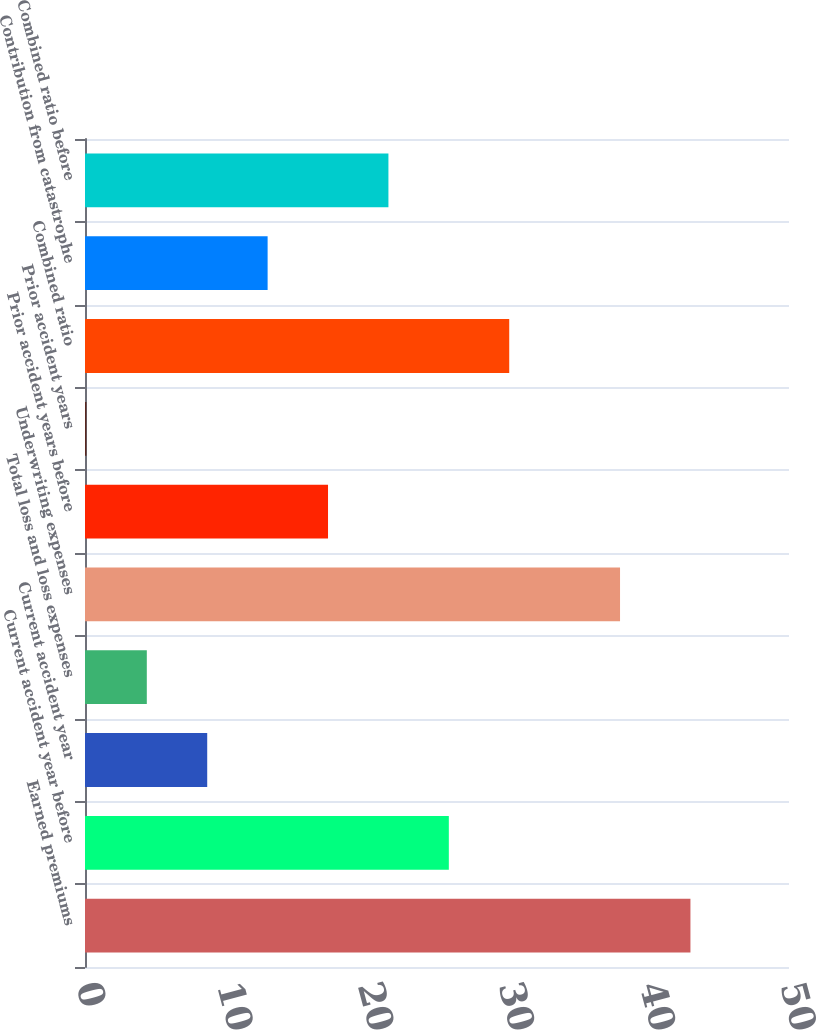Convert chart to OTSL. <chart><loc_0><loc_0><loc_500><loc_500><bar_chart><fcel>Earned premiums<fcel>Current accident year before<fcel>Current accident year<fcel>Total loss and loss expenses<fcel>Underwriting expenses<fcel>Prior accident years before<fcel>Prior accident years<fcel>Combined ratio<fcel>Contribution from catastrophe<fcel>Combined ratio before<nl><fcel>43<fcel>25.84<fcel>8.68<fcel>4.39<fcel>38<fcel>17.26<fcel>0.1<fcel>30.13<fcel>12.97<fcel>21.55<nl></chart> 